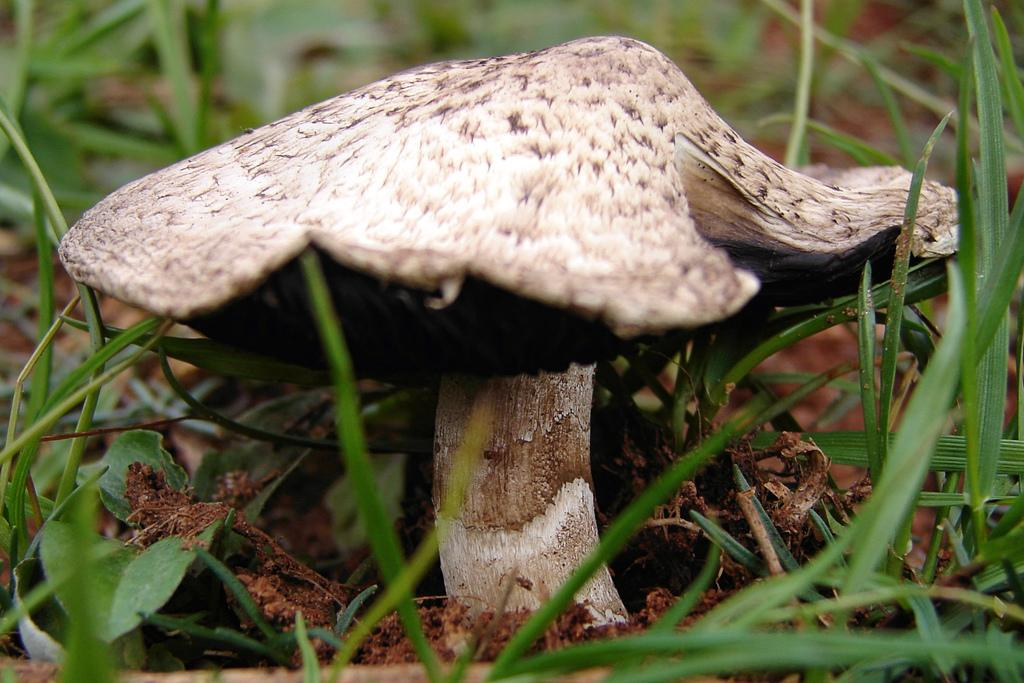What is the main subject of the image? The main subject of the image is a mushroom. Where is the mushroom located in the image? The mushroom is on the ground. Is the mushroom stuck in quicksand in the image? There is no quicksand present in the image, and the mushroom is simply on the ground. 